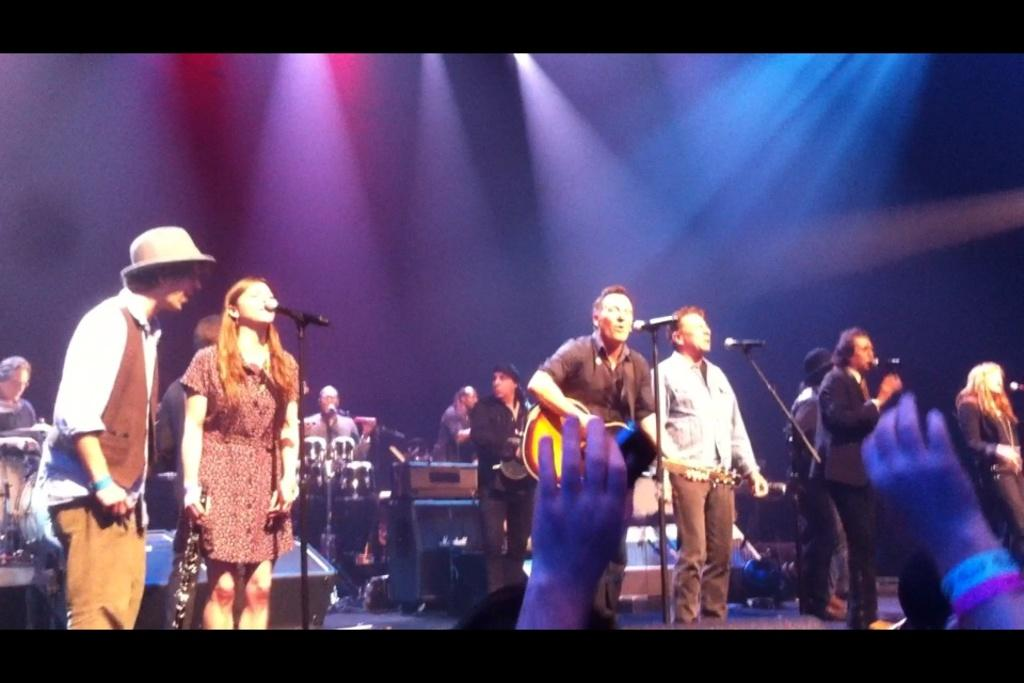What is happening in the image involving a group of persons? There is a group of persons performing in the image. Where is the performance taking place? The performance is taking place on a dais. What can be seen in the background of the image? There are musical instruments and lights visible in the background of the image. What is the name of the river that forms the border in the image? There is no river or border present in the image; it features a group of persons performing on a dais with musical instruments and lights in the background. 